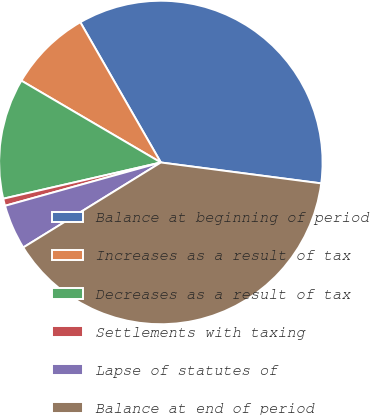<chart> <loc_0><loc_0><loc_500><loc_500><pie_chart><fcel>Balance at beginning of period<fcel>Increases as a result of tax<fcel>Decreases as a result of tax<fcel>Settlements with taxing<fcel>Lapse of statutes of<fcel>Balance at end of period<nl><fcel>35.36%<fcel>8.26%<fcel>12.04%<fcel>0.72%<fcel>4.49%<fcel>39.13%<nl></chart> 